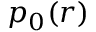<formula> <loc_0><loc_0><loc_500><loc_500>p _ { 0 } ( r )</formula> 